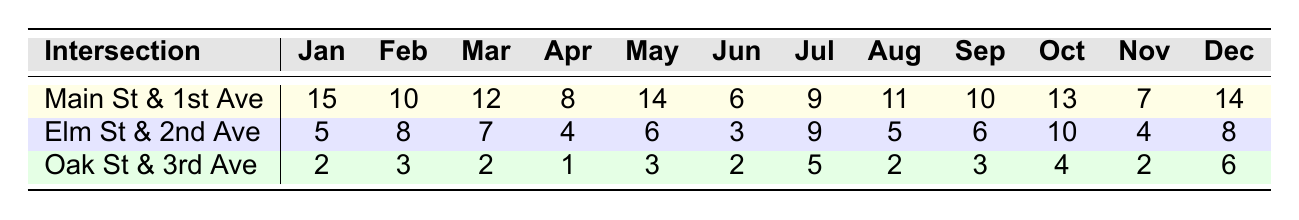What was the total number of accidents at Main St & 1st Ave in 2021? To find the total accidents at Main St & 1st Ave, sum the accident counts from each month: 15 + 10 + 12 + 8 + 14 + 6 + 9 + 11 + 10 + 13 + 7 + 14 =  15 + 10 = 25, 25 + 12 = 37, 37 + 8 = 45, 45 + 14 = 59, 59 + 6 = 65, 65 + 9 = 74, 74 + 11 = 85, 85 + 10 = 95, 95 + 13 = 108, 108 + 7 = 115, 115 + 14 = 129
Answer: 129 Which intersection had the highest number of accidents in June 2021? Looking at the accident counts for June across all intersections, Main St & 1st Ave had 6, Elm St & 2nd Ave had 3, and Oak St & 3rd Ave had 2. The highest is therefore at Main St & 1st Ave with 6 accidents.
Answer: Main St & 1st Ave What is the month with the least number of accidents at Elm St & 2nd Ave? Review the accident counts for each month and identify the lowest value: 5 (Jan), 8 (Feb), 7 (Mar), 4 (Apr), 6 (May), 3 (Jun), 9 (Jul), 5 (Aug), 6 (Sep), 10 (Oct), 4 (Nov), 8 (Dec). The minimum is 3 in June.
Answer: June What was the total number of accidents across all intersections in April 2021? Sum the accidents for each intersection in April: Main St & 1st Ave has 8, Elm St & 2nd Ave has 4, and Oak St & 3rd Ave has 1. Therefore, the total is 8 + 4 + 1 = 13.
Answer: 13 Does Elm St & 2nd Ave have more accidents in the summer months (June, July, August) than Oak St & 3rd Ave? First, calculate summer totals for both intersections: Elm St & 2nd Ave: 3 (Jun) + 9 (Jul) + 5 (Aug) = 17. Oak St & 3rd Ave: 2 (Jun) + 5 (Jul) + 2 (Aug) = 9. Since 17 > 9, Elm St & 2nd Ave has more accidents in summer.
Answer: Yes What is the average number of accidents per month at Oak St & 3rd Ave? Add the accident counts for each month: 2 + 3 + 2 + 1 + 3 + 2 + 5 + 2 + 3 + 4 + 2 + 6 = 34. Divide by the number of months (12): 34 / 12 = 2.83.
Answer: 2.83 Which intersection had the least total accidents in 2021? Calculate the total accidents for each intersection: Main St & 1st Ave: 129, Elm St & 2nd Ave: 69, and Oak St & 3rd Ave: 29. The lowest total is at Oak St & 3rd Ave with 29 accidents.
Answer: Oak St & 3rd Ave What percentage of accidents in December 2021 occurred at Main St & 1st Ave? There were 14 accidents at Main St & 1st Ave and 8 at Elm St & 2nd Ave and 6 at Oak St & 3rd Ave in December, giving a total of 14 + 8 + 6 = 28. The percentage is (14 / 28) * 100 = 50%.
Answer: 50% 